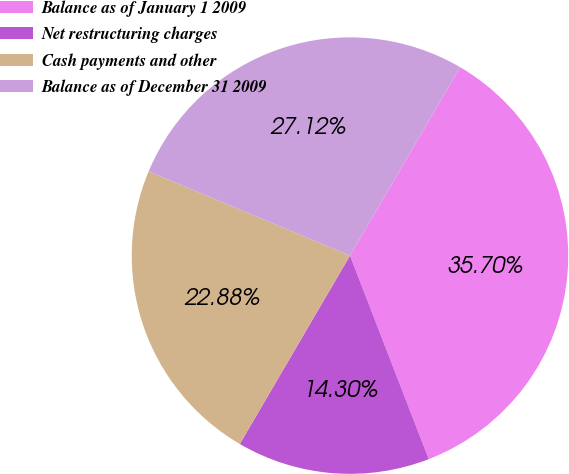Convert chart. <chart><loc_0><loc_0><loc_500><loc_500><pie_chart><fcel>Balance as of January 1 2009<fcel>Net restructuring charges<fcel>Cash payments and other<fcel>Balance as of December 31 2009<nl><fcel>35.7%<fcel>14.3%<fcel>22.88%<fcel>27.12%<nl></chart> 